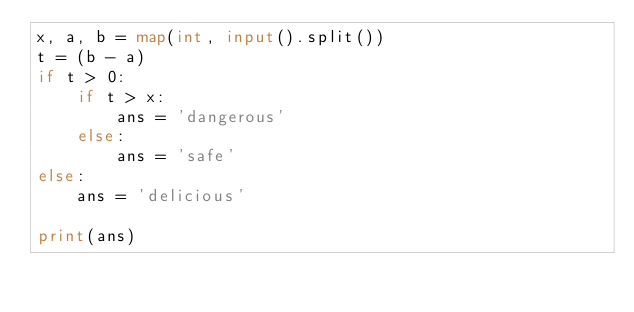<code> <loc_0><loc_0><loc_500><loc_500><_Python_>x, a, b = map(int, input().split())
t = (b - a)
if t > 0:
    if t > x:
        ans = 'dangerous'
    else:
        ans = 'safe'
else:
    ans = 'delicious'

print(ans)</code> 